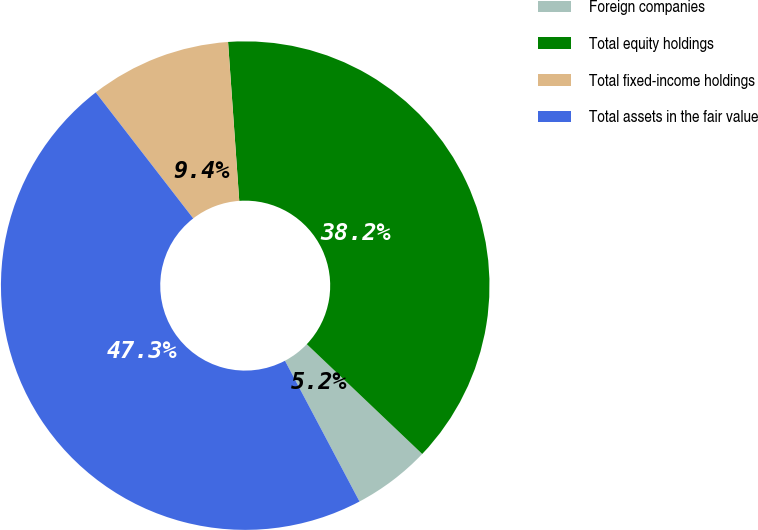Convert chart to OTSL. <chart><loc_0><loc_0><loc_500><loc_500><pie_chart><fcel>Foreign companies<fcel>Total equity holdings<fcel>Total fixed-income holdings<fcel>Total assets in the fair value<nl><fcel>5.15%<fcel>38.22%<fcel>9.36%<fcel>47.27%<nl></chart> 